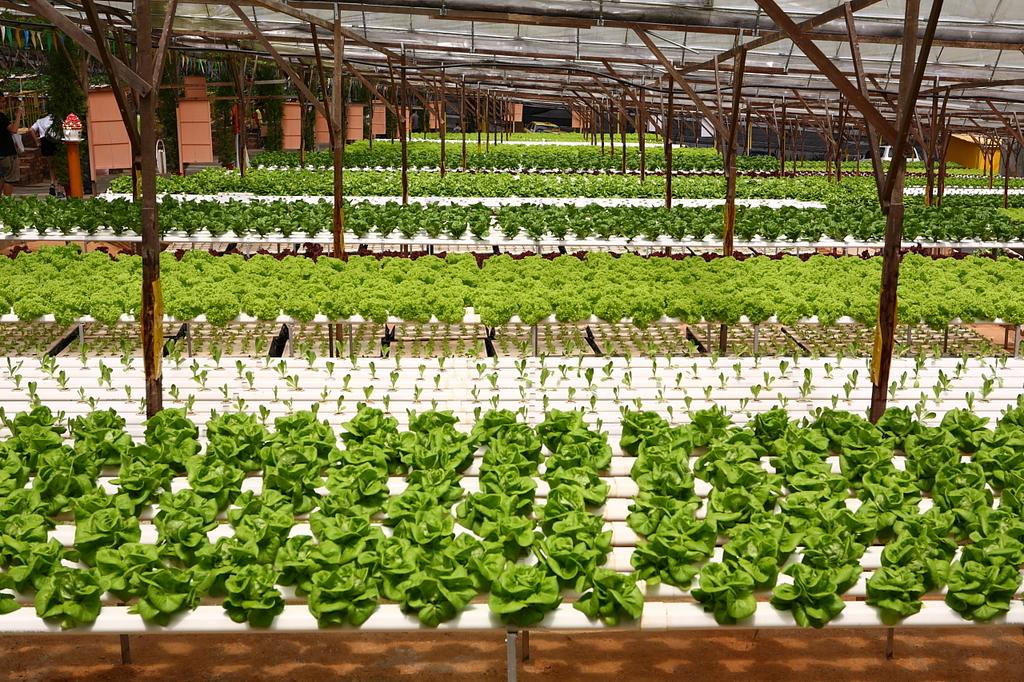What type of objects are located at the bottom of the image? There are plants at the bottom of the image. Where are the people in the image positioned? The people are standing on the left side of the image. What structure is visible at the top of the image? There is a roof visible at the top of the image. What type of linear objects can be seen in the image? There are rods present in the image. What type of apparatus is being used by the people in the image? There is no apparatus visible in the image; the people are simply standing on the left side. How does the behavior of the plants at the bottom of the image differ from the behavior of the people on the left side? The provided facts do not mention any behavior of the plants or people, so we cannot compare their behaviors. --- Facts: 1. There is a person sitting on a chair in the image. 2. The person is holding a book. 3. There is a table next to the chair. 4. There is a lamp on the table. 5. The background of the image is a wall. Absurd Topics: parrot, ocean, bicycle Conversation: What is the person in the image doing? The person is sitting on a chair in the image. What object is the person holding? The person is holding a book. What piece of furniture is located next to the chair? There is a table next to the chair. What object is on the table? There is a lamp on the table. What can be seen behind the person in the image? The background of the image is a wall. Reasoning: Let's think step by step in order to produce the conversation. We start by identifying the main subject in the image, which is the person sitting on a chair. Then, we expand the conversation to include other items that are also visible, such as the book, table, lamp, and wall. Each question is designed to elicit a specific detail about the image that is known from the provided facts. Absurd Question/Answer: Can you see a parrot sitting on the person's shoulder in the image? No, there is no parrot present in the image. Is the person riding a bicycle in the image? No, the person is sitting on a chair, not riding a bicycle. 